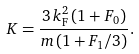<formula> <loc_0><loc_0><loc_500><loc_500>K = \frac { 3 \, k _ { \text {F} } ^ { 2 } \, ( 1 + F _ { 0 } ) } { m \, ( 1 + F _ { 1 } / 3 ) } .</formula> 